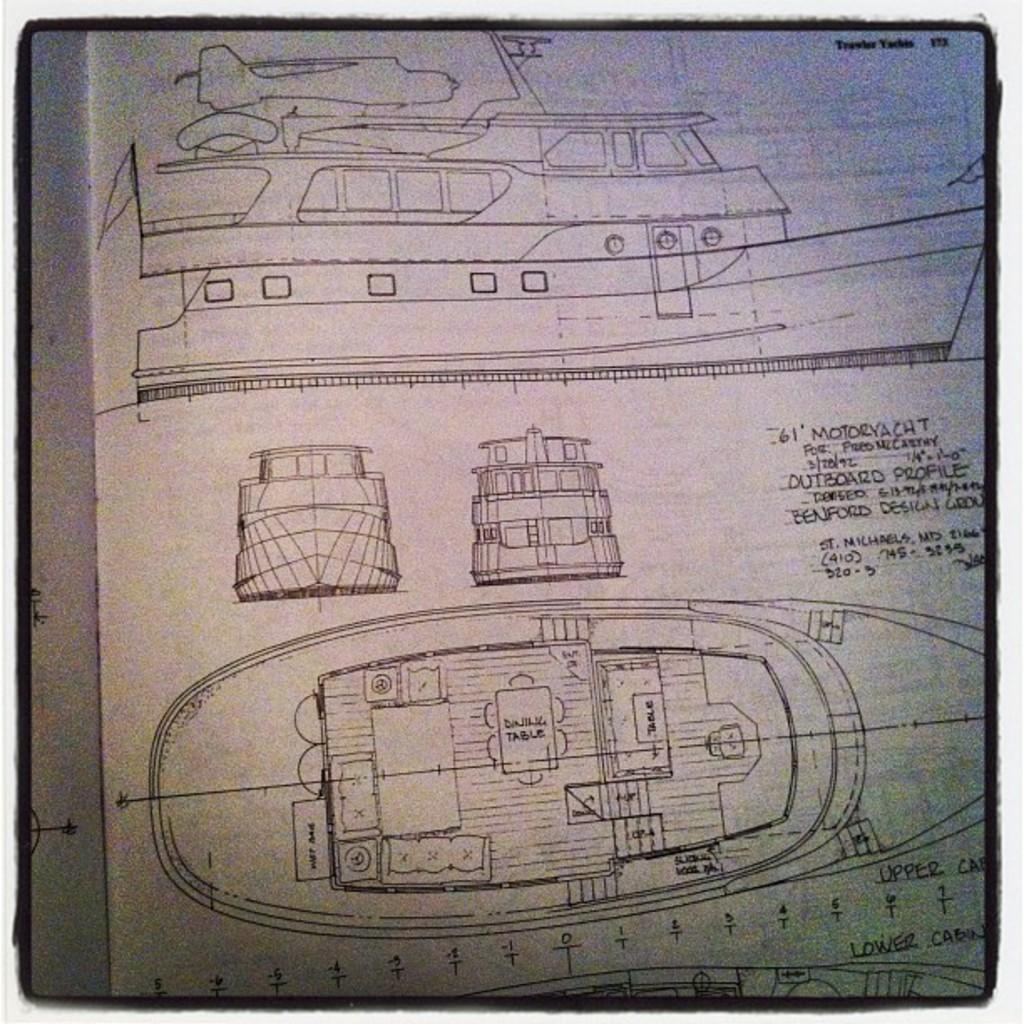What type of objects are depicted in the sample designs in the image? The sample designs in the image contain designs of boats and ships. What is the color of the paper on which the designs are drawn? The designs are on a white paper. What specific parts of boats and ships can be seen in the designs? The designs depict parts of boats and ships. Is there any text accompanying the designs on the paper? Yes, there is text written on the paper. What type of flowers are growing on the ship in the image? There are no flowers depicted in the image; it contains designs of boats and ships on a white paper. 